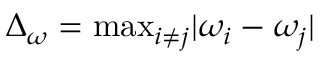<formula> <loc_0><loc_0><loc_500><loc_500>\Delta _ { \omega } = \max _ { i \neq j } | \omega _ { i } - \omega _ { j } |</formula> 